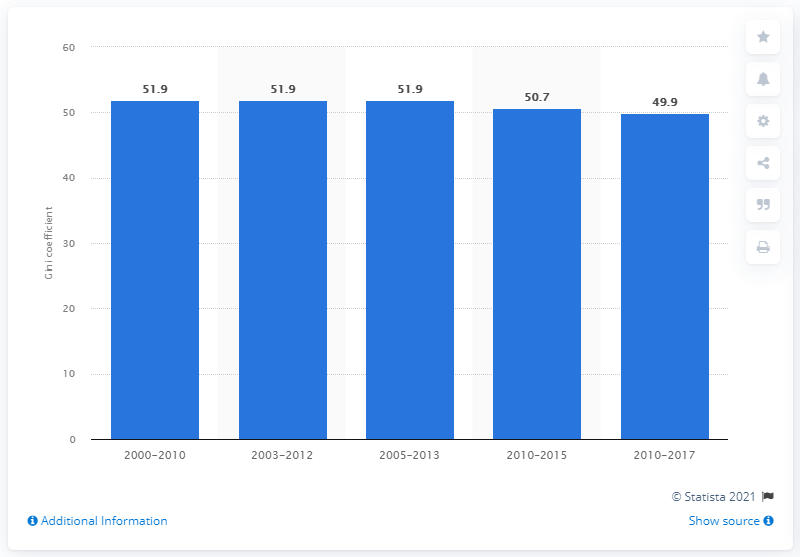List a handful of essential elements in this visual. According to the data available as of 2017, Panama's Gini coefficient was 49.9, indicating a high level of income inequality in the country. 